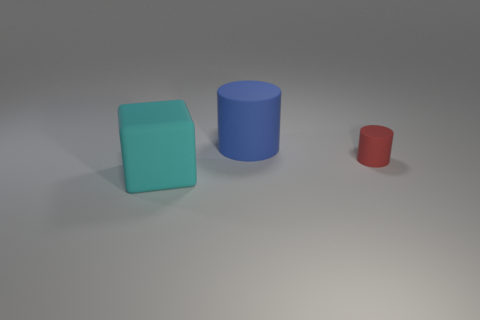Subtract all blue blocks. Subtract all brown cylinders. How many blocks are left? 1 Add 1 big rubber cylinders. How many objects exist? 4 Subtract all cylinders. How many objects are left? 1 Add 3 big matte blocks. How many big matte blocks are left? 4 Add 3 small red rubber things. How many small red rubber things exist? 4 Subtract 0 brown blocks. How many objects are left? 3 Subtract all cylinders. Subtract all blue things. How many objects are left? 0 